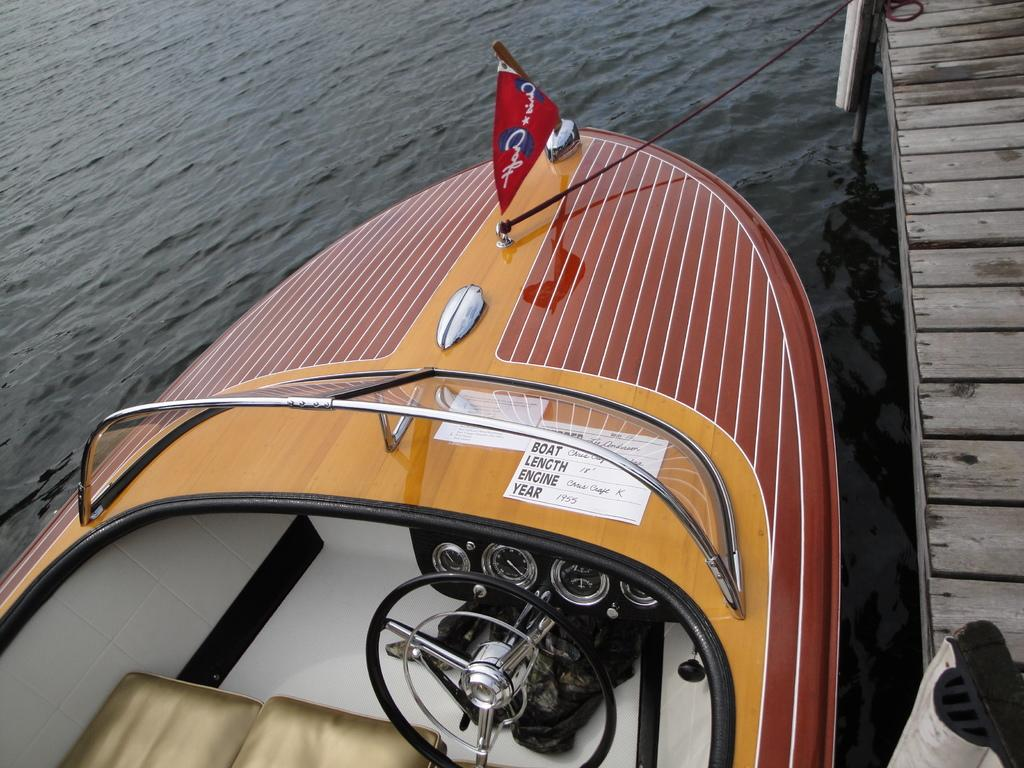What is the main subject in the image? The main subject in the image is water. What is on the water in the image? There is a motorboat on the water. What can be seen on the motorboat? The motorboat has a red color flag. What is located on the right side of the image? There is a platform on the right side of the image. How does the motorboat use the brake while on the water? Motorboats do not have brakes like cars; they slow down by reducing engine power or using reverse thrust. In the image, there is no indication of the motorboat using any braking mechanism. 